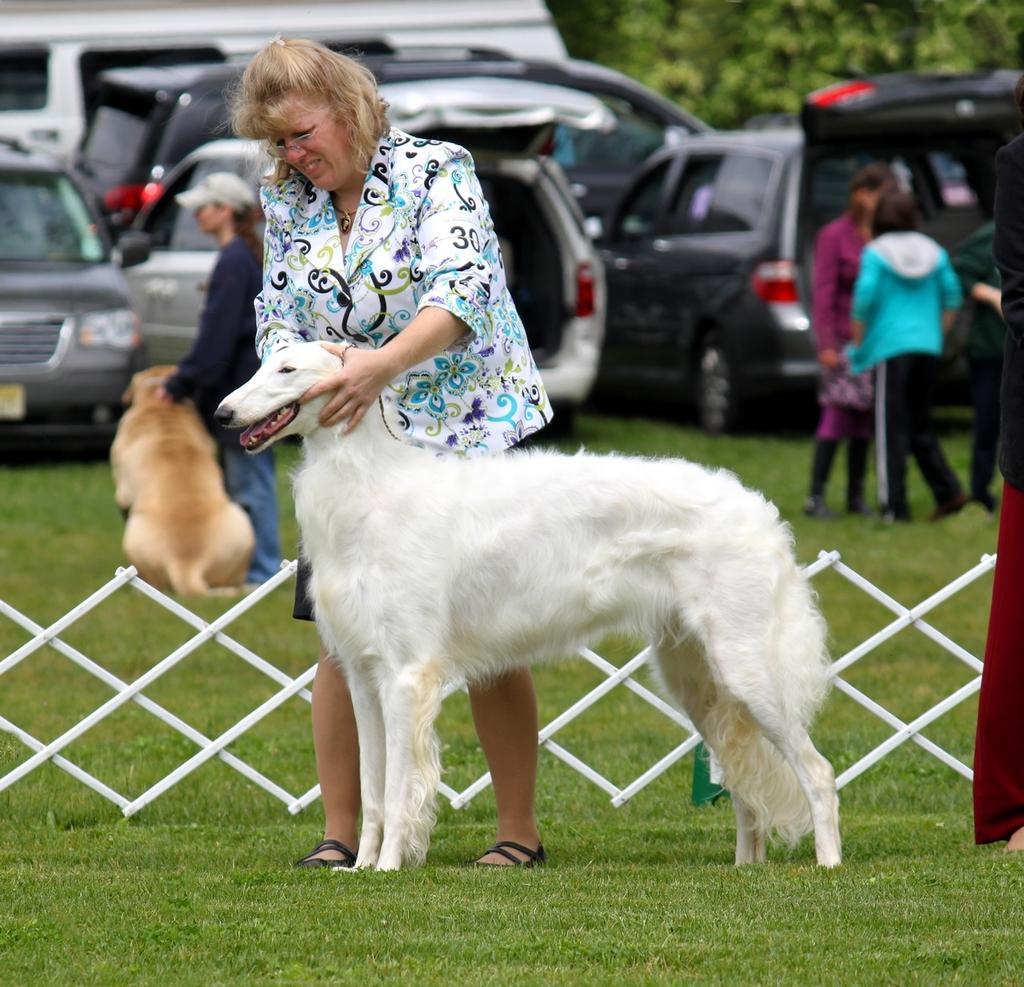Could you give a brief overview of what you see in this image? This image is taken in a garden. In the middle there is a woman her hair is short , she is holding a dog. In the background there are many cars ,trees and some people. At bottom there is a grass. 